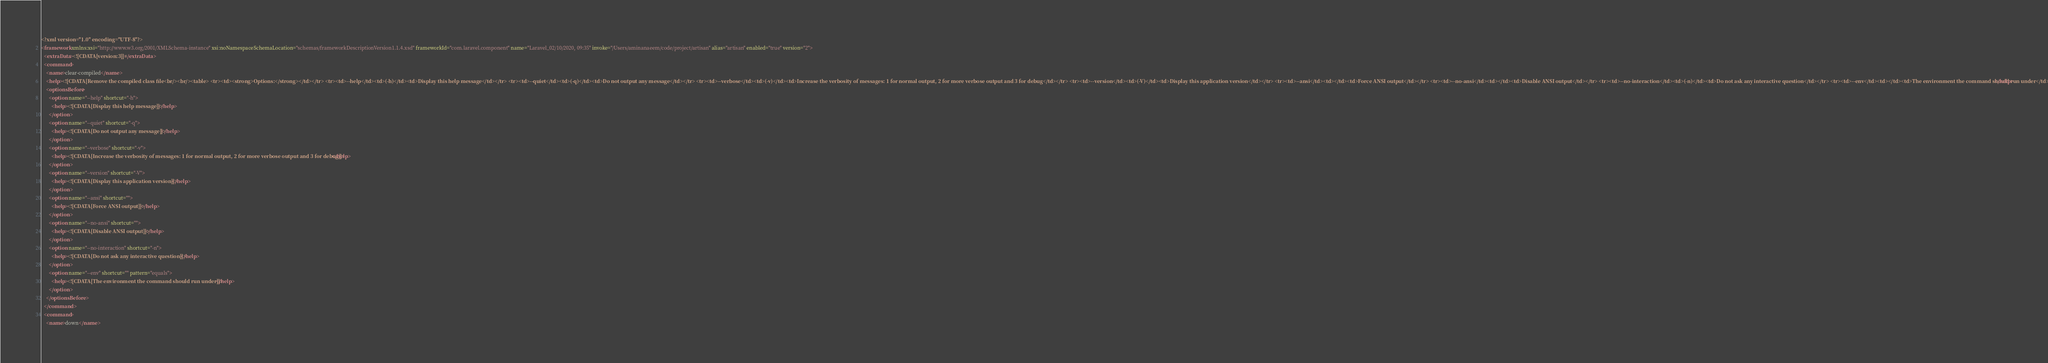<code> <loc_0><loc_0><loc_500><loc_500><_XML_><?xml version="1.0" encoding="UTF-8"?>
<framework xmlns:xsi="http://www.w3.org/2001/XMLSchema-instance" xsi:noNamespaceSchemaLocation="schemas/frameworkDescriptionVersion1.1.4.xsd" frameworkId="com.laravel.component" name="Laravel_02/10/2020, 09:35" invoke="/Users/aminanaeem/code/project/artisan" alias="artisan" enabled="true" version="2">
  <extraData><![CDATA[version:3]]></extraData>
  <command>
    <name>clear-compiled</name>
    <help><![CDATA[Remove the compiled class file<br/><br/><table> <tr><td><strong>Options:</strong></td></tr> <tr><td>--help</td><td>(-h)</td><td>Display this help message</td></tr> <tr><td>--quiet</td><td>(-q)</td><td>Do not output any message</td></tr> <tr><td>--verbose</td><td>(-v)</td><td>Increase the verbosity of messages: 1 for normal output, 2 for more verbose output and 3 for debug</td></tr> <tr><td>--version</td><td>(-V)</td><td>Display this application version</td></tr> <tr><td>--ansi</td><td></td><td>Force ANSI output</td></tr> <tr><td>--no-ansi</td><td></td><td>Disable ANSI output</td></tr> <tr><td>--no-interaction</td><td>(-n)</td><td>Do not ask any interactive question</td></tr> <tr><td>--env</td><td></td><td>The environment the command should run under</td></tr> </table> <br/>]]></help>
    <optionsBefore>
      <option name="--help" shortcut="-h">
        <help><![CDATA[Display this help message]]></help>
      </option>
      <option name="--quiet" shortcut="-q">
        <help><![CDATA[Do not output any message]]></help>
      </option>
      <option name="--verbose" shortcut="-v">
        <help><![CDATA[Increase the verbosity of messages: 1 for normal output, 2 for more verbose output and 3 for debug]]></help>
      </option>
      <option name="--version" shortcut="-V">
        <help><![CDATA[Display this application version]]></help>
      </option>
      <option name="--ansi" shortcut="">
        <help><![CDATA[Force ANSI output]]></help>
      </option>
      <option name="--no-ansi" shortcut="">
        <help><![CDATA[Disable ANSI output]]></help>
      </option>
      <option name="--no-interaction" shortcut="-n">
        <help><![CDATA[Do not ask any interactive question]]></help>
      </option>
      <option name="--env" shortcut="" pattern="equals">
        <help><![CDATA[The environment the command should run under]]></help>
      </option>
    </optionsBefore>
  </command>
  <command>
    <name>down</name></code> 